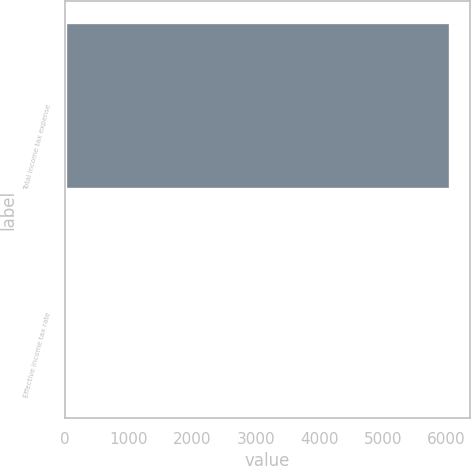<chart> <loc_0><loc_0><loc_500><loc_500><bar_chart><fcel>Total income tax expense<fcel>Effective income tax rate<nl><fcel>6065<fcel>29<nl></chart> 